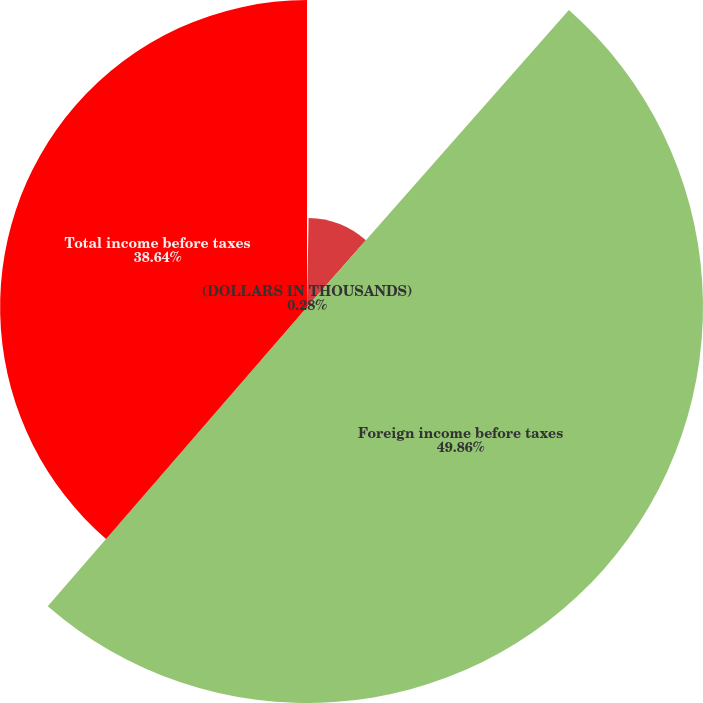<chart> <loc_0><loc_0><loc_500><loc_500><pie_chart><fcel>(DOLLARS IN THOUSANDS)<fcel>US loss before taxes<fcel>Foreign income before taxes<fcel>Total income before taxes<nl><fcel>0.28%<fcel>11.22%<fcel>49.86%<fcel>38.64%<nl></chart> 